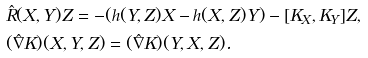Convert formula to latex. <formula><loc_0><loc_0><loc_500><loc_500>& \hat { R } ( X , Y ) Z = - ( h ( Y , Z ) X - h ( X , Z ) Y ) - [ K _ { X } , K _ { Y } ] Z , \\ & ( \hat { \nabla } K ) ( X , Y , Z ) = ( \hat { \nabla } K ) ( Y , X , Z ) .</formula> 